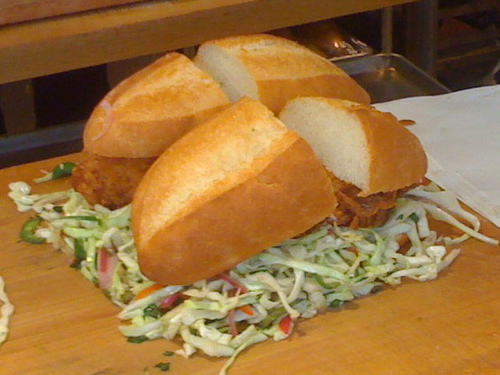Can you tell me what this sandwich is typically called? This looks like a po' boy, a traditional sandwich from Louisiana, usually filled with meat or fried seafood. 